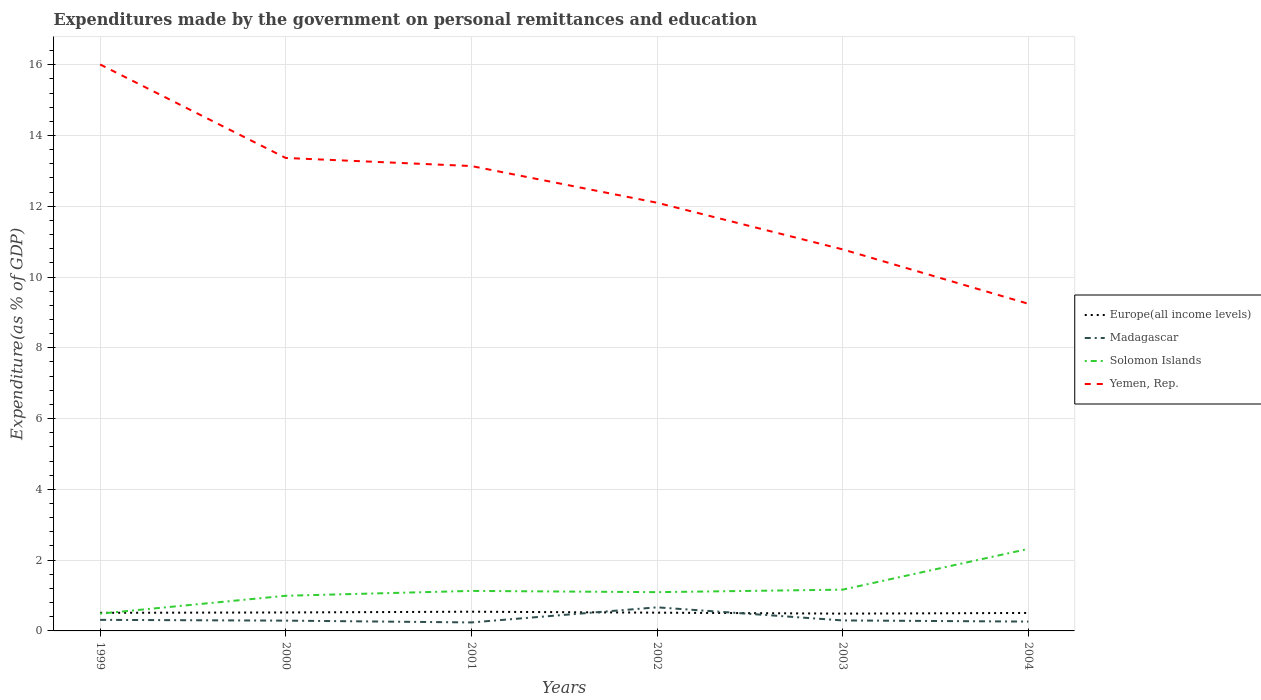How many different coloured lines are there?
Your answer should be very brief. 4. Across all years, what is the maximum expenditures made by the government on personal remittances and education in Madagascar?
Give a very brief answer. 0.24. In which year was the expenditures made by the government on personal remittances and education in Solomon Islands maximum?
Ensure brevity in your answer.  1999. What is the total expenditures made by the government on personal remittances and education in Madagascar in the graph?
Offer a terse response. 0.02. What is the difference between the highest and the second highest expenditures made by the government on personal remittances and education in Yemen, Rep.?
Your answer should be compact. 6.76. What is the difference between the highest and the lowest expenditures made by the government on personal remittances and education in Yemen, Rep.?
Offer a very short reply. 3. Is the expenditures made by the government on personal remittances and education in Yemen, Rep. strictly greater than the expenditures made by the government on personal remittances and education in Solomon Islands over the years?
Provide a succinct answer. No. How many years are there in the graph?
Give a very brief answer. 6. What is the difference between two consecutive major ticks on the Y-axis?
Keep it short and to the point. 2. How many legend labels are there?
Provide a short and direct response. 4. What is the title of the graph?
Provide a short and direct response. Expenditures made by the government on personal remittances and education. Does "Nepal" appear as one of the legend labels in the graph?
Offer a very short reply. No. What is the label or title of the X-axis?
Your answer should be very brief. Years. What is the label or title of the Y-axis?
Keep it short and to the point. Expenditure(as % of GDP). What is the Expenditure(as % of GDP) in Europe(all income levels) in 1999?
Your answer should be compact. 0.51. What is the Expenditure(as % of GDP) of Madagascar in 1999?
Provide a short and direct response. 0.31. What is the Expenditure(as % of GDP) in Solomon Islands in 1999?
Provide a succinct answer. 0.49. What is the Expenditure(as % of GDP) in Yemen, Rep. in 1999?
Keep it short and to the point. 16.01. What is the Expenditure(as % of GDP) in Europe(all income levels) in 2000?
Your response must be concise. 0.52. What is the Expenditure(as % of GDP) in Madagascar in 2000?
Your answer should be very brief. 0.29. What is the Expenditure(as % of GDP) in Solomon Islands in 2000?
Ensure brevity in your answer.  0.99. What is the Expenditure(as % of GDP) of Yemen, Rep. in 2000?
Your response must be concise. 13.37. What is the Expenditure(as % of GDP) of Europe(all income levels) in 2001?
Make the answer very short. 0.54. What is the Expenditure(as % of GDP) in Madagascar in 2001?
Offer a terse response. 0.24. What is the Expenditure(as % of GDP) of Solomon Islands in 2001?
Make the answer very short. 1.13. What is the Expenditure(as % of GDP) of Yemen, Rep. in 2001?
Offer a very short reply. 13.14. What is the Expenditure(as % of GDP) in Europe(all income levels) in 2002?
Provide a succinct answer. 0.52. What is the Expenditure(as % of GDP) in Madagascar in 2002?
Your response must be concise. 0.67. What is the Expenditure(as % of GDP) of Solomon Islands in 2002?
Your answer should be very brief. 1.1. What is the Expenditure(as % of GDP) in Yemen, Rep. in 2002?
Your answer should be compact. 12.1. What is the Expenditure(as % of GDP) in Europe(all income levels) in 2003?
Offer a terse response. 0.49. What is the Expenditure(as % of GDP) in Madagascar in 2003?
Your answer should be compact. 0.3. What is the Expenditure(as % of GDP) of Solomon Islands in 2003?
Make the answer very short. 1.17. What is the Expenditure(as % of GDP) of Yemen, Rep. in 2003?
Offer a very short reply. 10.78. What is the Expenditure(as % of GDP) of Europe(all income levels) in 2004?
Offer a very short reply. 0.51. What is the Expenditure(as % of GDP) of Madagascar in 2004?
Your response must be concise. 0.26. What is the Expenditure(as % of GDP) in Solomon Islands in 2004?
Offer a terse response. 2.32. What is the Expenditure(as % of GDP) in Yemen, Rep. in 2004?
Keep it short and to the point. 9.24. Across all years, what is the maximum Expenditure(as % of GDP) in Europe(all income levels)?
Your response must be concise. 0.54. Across all years, what is the maximum Expenditure(as % of GDP) of Madagascar?
Ensure brevity in your answer.  0.67. Across all years, what is the maximum Expenditure(as % of GDP) in Solomon Islands?
Your answer should be compact. 2.32. Across all years, what is the maximum Expenditure(as % of GDP) of Yemen, Rep.?
Provide a succinct answer. 16.01. Across all years, what is the minimum Expenditure(as % of GDP) of Europe(all income levels)?
Keep it short and to the point. 0.49. Across all years, what is the minimum Expenditure(as % of GDP) in Madagascar?
Give a very brief answer. 0.24. Across all years, what is the minimum Expenditure(as % of GDP) of Solomon Islands?
Offer a terse response. 0.49. Across all years, what is the minimum Expenditure(as % of GDP) of Yemen, Rep.?
Your response must be concise. 9.24. What is the total Expenditure(as % of GDP) of Europe(all income levels) in the graph?
Provide a short and direct response. 3.09. What is the total Expenditure(as % of GDP) of Madagascar in the graph?
Offer a terse response. 2.07. What is the total Expenditure(as % of GDP) in Solomon Islands in the graph?
Make the answer very short. 7.19. What is the total Expenditure(as % of GDP) of Yemen, Rep. in the graph?
Give a very brief answer. 74.64. What is the difference between the Expenditure(as % of GDP) of Europe(all income levels) in 1999 and that in 2000?
Your answer should be compact. -0.01. What is the difference between the Expenditure(as % of GDP) in Madagascar in 1999 and that in 2000?
Your response must be concise. 0.02. What is the difference between the Expenditure(as % of GDP) in Solomon Islands in 1999 and that in 2000?
Your response must be concise. -0.5. What is the difference between the Expenditure(as % of GDP) in Yemen, Rep. in 1999 and that in 2000?
Offer a very short reply. 2.64. What is the difference between the Expenditure(as % of GDP) in Europe(all income levels) in 1999 and that in 2001?
Your answer should be compact. -0.03. What is the difference between the Expenditure(as % of GDP) in Madagascar in 1999 and that in 2001?
Provide a succinct answer. 0.07. What is the difference between the Expenditure(as % of GDP) of Solomon Islands in 1999 and that in 2001?
Your response must be concise. -0.64. What is the difference between the Expenditure(as % of GDP) of Yemen, Rep. in 1999 and that in 2001?
Offer a terse response. 2.87. What is the difference between the Expenditure(as % of GDP) of Europe(all income levels) in 1999 and that in 2002?
Ensure brevity in your answer.  -0. What is the difference between the Expenditure(as % of GDP) of Madagascar in 1999 and that in 2002?
Make the answer very short. -0.35. What is the difference between the Expenditure(as % of GDP) in Solomon Islands in 1999 and that in 2002?
Provide a short and direct response. -0.61. What is the difference between the Expenditure(as % of GDP) in Yemen, Rep. in 1999 and that in 2002?
Ensure brevity in your answer.  3.91. What is the difference between the Expenditure(as % of GDP) of Europe(all income levels) in 1999 and that in 2003?
Give a very brief answer. 0.02. What is the difference between the Expenditure(as % of GDP) of Madagascar in 1999 and that in 2003?
Give a very brief answer. 0.02. What is the difference between the Expenditure(as % of GDP) in Solomon Islands in 1999 and that in 2003?
Keep it short and to the point. -0.68. What is the difference between the Expenditure(as % of GDP) in Yemen, Rep. in 1999 and that in 2003?
Provide a short and direct response. 5.23. What is the difference between the Expenditure(as % of GDP) of Europe(all income levels) in 1999 and that in 2004?
Provide a short and direct response. 0. What is the difference between the Expenditure(as % of GDP) in Madagascar in 1999 and that in 2004?
Give a very brief answer. 0.05. What is the difference between the Expenditure(as % of GDP) of Solomon Islands in 1999 and that in 2004?
Make the answer very short. -1.83. What is the difference between the Expenditure(as % of GDP) of Yemen, Rep. in 1999 and that in 2004?
Your answer should be very brief. 6.76. What is the difference between the Expenditure(as % of GDP) of Europe(all income levels) in 2000 and that in 2001?
Provide a succinct answer. -0.02. What is the difference between the Expenditure(as % of GDP) of Madagascar in 2000 and that in 2001?
Give a very brief answer. 0.05. What is the difference between the Expenditure(as % of GDP) in Solomon Islands in 2000 and that in 2001?
Provide a succinct answer. -0.14. What is the difference between the Expenditure(as % of GDP) of Yemen, Rep. in 2000 and that in 2001?
Keep it short and to the point. 0.23. What is the difference between the Expenditure(as % of GDP) of Europe(all income levels) in 2000 and that in 2002?
Provide a short and direct response. 0.01. What is the difference between the Expenditure(as % of GDP) in Madagascar in 2000 and that in 2002?
Ensure brevity in your answer.  -0.38. What is the difference between the Expenditure(as % of GDP) in Solomon Islands in 2000 and that in 2002?
Your answer should be compact. -0.1. What is the difference between the Expenditure(as % of GDP) in Yemen, Rep. in 2000 and that in 2002?
Your answer should be compact. 1.26. What is the difference between the Expenditure(as % of GDP) in Europe(all income levels) in 2000 and that in 2003?
Your answer should be compact. 0.03. What is the difference between the Expenditure(as % of GDP) in Madagascar in 2000 and that in 2003?
Offer a terse response. -0.01. What is the difference between the Expenditure(as % of GDP) in Solomon Islands in 2000 and that in 2003?
Offer a terse response. -0.17. What is the difference between the Expenditure(as % of GDP) in Yemen, Rep. in 2000 and that in 2003?
Give a very brief answer. 2.58. What is the difference between the Expenditure(as % of GDP) of Europe(all income levels) in 2000 and that in 2004?
Provide a succinct answer. 0.01. What is the difference between the Expenditure(as % of GDP) of Madagascar in 2000 and that in 2004?
Make the answer very short. 0.03. What is the difference between the Expenditure(as % of GDP) in Solomon Islands in 2000 and that in 2004?
Ensure brevity in your answer.  -1.32. What is the difference between the Expenditure(as % of GDP) of Yemen, Rep. in 2000 and that in 2004?
Your answer should be compact. 4.12. What is the difference between the Expenditure(as % of GDP) of Europe(all income levels) in 2001 and that in 2002?
Your answer should be very brief. 0.03. What is the difference between the Expenditure(as % of GDP) in Madagascar in 2001 and that in 2002?
Offer a very short reply. -0.43. What is the difference between the Expenditure(as % of GDP) of Solomon Islands in 2001 and that in 2002?
Your answer should be very brief. 0.04. What is the difference between the Expenditure(as % of GDP) of Yemen, Rep. in 2001 and that in 2002?
Offer a terse response. 1.04. What is the difference between the Expenditure(as % of GDP) in Europe(all income levels) in 2001 and that in 2003?
Offer a very short reply. 0.05. What is the difference between the Expenditure(as % of GDP) of Madagascar in 2001 and that in 2003?
Ensure brevity in your answer.  -0.06. What is the difference between the Expenditure(as % of GDP) of Solomon Islands in 2001 and that in 2003?
Ensure brevity in your answer.  -0.04. What is the difference between the Expenditure(as % of GDP) in Yemen, Rep. in 2001 and that in 2003?
Ensure brevity in your answer.  2.36. What is the difference between the Expenditure(as % of GDP) of Europe(all income levels) in 2001 and that in 2004?
Make the answer very short. 0.04. What is the difference between the Expenditure(as % of GDP) of Madagascar in 2001 and that in 2004?
Offer a very short reply. -0.02. What is the difference between the Expenditure(as % of GDP) of Solomon Islands in 2001 and that in 2004?
Make the answer very short. -1.19. What is the difference between the Expenditure(as % of GDP) of Yemen, Rep. in 2001 and that in 2004?
Ensure brevity in your answer.  3.89. What is the difference between the Expenditure(as % of GDP) in Europe(all income levels) in 2002 and that in 2003?
Provide a succinct answer. 0.03. What is the difference between the Expenditure(as % of GDP) in Madagascar in 2002 and that in 2003?
Make the answer very short. 0.37. What is the difference between the Expenditure(as % of GDP) of Solomon Islands in 2002 and that in 2003?
Offer a terse response. -0.07. What is the difference between the Expenditure(as % of GDP) in Yemen, Rep. in 2002 and that in 2003?
Provide a succinct answer. 1.32. What is the difference between the Expenditure(as % of GDP) of Europe(all income levels) in 2002 and that in 2004?
Your answer should be very brief. 0.01. What is the difference between the Expenditure(as % of GDP) in Madagascar in 2002 and that in 2004?
Ensure brevity in your answer.  0.4. What is the difference between the Expenditure(as % of GDP) in Solomon Islands in 2002 and that in 2004?
Your answer should be very brief. -1.22. What is the difference between the Expenditure(as % of GDP) of Yemen, Rep. in 2002 and that in 2004?
Provide a succinct answer. 2.86. What is the difference between the Expenditure(as % of GDP) in Europe(all income levels) in 2003 and that in 2004?
Offer a terse response. -0.02. What is the difference between the Expenditure(as % of GDP) in Madagascar in 2003 and that in 2004?
Ensure brevity in your answer.  0.03. What is the difference between the Expenditure(as % of GDP) of Solomon Islands in 2003 and that in 2004?
Make the answer very short. -1.15. What is the difference between the Expenditure(as % of GDP) in Yemen, Rep. in 2003 and that in 2004?
Give a very brief answer. 1.54. What is the difference between the Expenditure(as % of GDP) of Europe(all income levels) in 1999 and the Expenditure(as % of GDP) of Madagascar in 2000?
Your response must be concise. 0.22. What is the difference between the Expenditure(as % of GDP) in Europe(all income levels) in 1999 and the Expenditure(as % of GDP) in Solomon Islands in 2000?
Your answer should be compact. -0.48. What is the difference between the Expenditure(as % of GDP) in Europe(all income levels) in 1999 and the Expenditure(as % of GDP) in Yemen, Rep. in 2000?
Ensure brevity in your answer.  -12.85. What is the difference between the Expenditure(as % of GDP) of Madagascar in 1999 and the Expenditure(as % of GDP) of Solomon Islands in 2000?
Make the answer very short. -0.68. What is the difference between the Expenditure(as % of GDP) of Madagascar in 1999 and the Expenditure(as % of GDP) of Yemen, Rep. in 2000?
Your answer should be very brief. -13.05. What is the difference between the Expenditure(as % of GDP) in Solomon Islands in 1999 and the Expenditure(as % of GDP) in Yemen, Rep. in 2000?
Offer a very short reply. -12.88. What is the difference between the Expenditure(as % of GDP) of Europe(all income levels) in 1999 and the Expenditure(as % of GDP) of Madagascar in 2001?
Provide a short and direct response. 0.27. What is the difference between the Expenditure(as % of GDP) in Europe(all income levels) in 1999 and the Expenditure(as % of GDP) in Solomon Islands in 2001?
Ensure brevity in your answer.  -0.62. What is the difference between the Expenditure(as % of GDP) of Europe(all income levels) in 1999 and the Expenditure(as % of GDP) of Yemen, Rep. in 2001?
Keep it short and to the point. -12.63. What is the difference between the Expenditure(as % of GDP) in Madagascar in 1999 and the Expenditure(as % of GDP) in Solomon Islands in 2001?
Keep it short and to the point. -0.82. What is the difference between the Expenditure(as % of GDP) of Madagascar in 1999 and the Expenditure(as % of GDP) of Yemen, Rep. in 2001?
Make the answer very short. -12.83. What is the difference between the Expenditure(as % of GDP) in Solomon Islands in 1999 and the Expenditure(as % of GDP) in Yemen, Rep. in 2001?
Your response must be concise. -12.65. What is the difference between the Expenditure(as % of GDP) of Europe(all income levels) in 1999 and the Expenditure(as % of GDP) of Madagascar in 2002?
Your answer should be very brief. -0.16. What is the difference between the Expenditure(as % of GDP) in Europe(all income levels) in 1999 and the Expenditure(as % of GDP) in Solomon Islands in 2002?
Provide a short and direct response. -0.58. What is the difference between the Expenditure(as % of GDP) of Europe(all income levels) in 1999 and the Expenditure(as % of GDP) of Yemen, Rep. in 2002?
Offer a very short reply. -11.59. What is the difference between the Expenditure(as % of GDP) of Madagascar in 1999 and the Expenditure(as % of GDP) of Solomon Islands in 2002?
Give a very brief answer. -0.78. What is the difference between the Expenditure(as % of GDP) of Madagascar in 1999 and the Expenditure(as % of GDP) of Yemen, Rep. in 2002?
Make the answer very short. -11.79. What is the difference between the Expenditure(as % of GDP) in Solomon Islands in 1999 and the Expenditure(as % of GDP) in Yemen, Rep. in 2002?
Give a very brief answer. -11.61. What is the difference between the Expenditure(as % of GDP) in Europe(all income levels) in 1999 and the Expenditure(as % of GDP) in Madagascar in 2003?
Ensure brevity in your answer.  0.22. What is the difference between the Expenditure(as % of GDP) in Europe(all income levels) in 1999 and the Expenditure(as % of GDP) in Solomon Islands in 2003?
Give a very brief answer. -0.65. What is the difference between the Expenditure(as % of GDP) in Europe(all income levels) in 1999 and the Expenditure(as % of GDP) in Yemen, Rep. in 2003?
Provide a short and direct response. -10.27. What is the difference between the Expenditure(as % of GDP) in Madagascar in 1999 and the Expenditure(as % of GDP) in Solomon Islands in 2003?
Provide a succinct answer. -0.85. What is the difference between the Expenditure(as % of GDP) of Madagascar in 1999 and the Expenditure(as % of GDP) of Yemen, Rep. in 2003?
Offer a terse response. -10.47. What is the difference between the Expenditure(as % of GDP) of Solomon Islands in 1999 and the Expenditure(as % of GDP) of Yemen, Rep. in 2003?
Keep it short and to the point. -10.29. What is the difference between the Expenditure(as % of GDP) of Europe(all income levels) in 1999 and the Expenditure(as % of GDP) of Madagascar in 2004?
Your response must be concise. 0.25. What is the difference between the Expenditure(as % of GDP) in Europe(all income levels) in 1999 and the Expenditure(as % of GDP) in Solomon Islands in 2004?
Provide a succinct answer. -1.81. What is the difference between the Expenditure(as % of GDP) in Europe(all income levels) in 1999 and the Expenditure(as % of GDP) in Yemen, Rep. in 2004?
Provide a short and direct response. -8.73. What is the difference between the Expenditure(as % of GDP) in Madagascar in 1999 and the Expenditure(as % of GDP) in Solomon Islands in 2004?
Provide a succinct answer. -2.01. What is the difference between the Expenditure(as % of GDP) of Madagascar in 1999 and the Expenditure(as % of GDP) of Yemen, Rep. in 2004?
Make the answer very short. -8.93. What is the difference between the Expenditure(as % of GDP) of Solomon Islands in 1999 and the Expenditure(as % of GDP) of Yemen, Rep. in 2004?
Make the answer very short. -8.76. What is the difference between the Expenditure(as % of GDP) of Europe(all income levels) in 2000 and the Expenditure(as % of GDP) of Madagascar in 2001?
Provide a short and direct response. 0.28. What is the difference between the Expenditure(as % of GDP) of Europe(all income levels) in 2000 and the Expenditure(as % of GDP) of Solomon Islands in 2001?
Make the answer very short. -0.61. What is the difference between the Expenditure(as % of GDP) of Europe(all income levels) in 2000 and the Expenditure(as % of GDP) of Yemen, Rep. in 2001?
Your response must be concise. -12.62. What is the difference between the Expenditure(as % of GDP) in Madagascar in 2000 and the Expenditure(as % of GDP) in Solomon Islands in 2001?
Offer a terse response. -0.84. What is the difference between the Expenditure(as % of GDP) of Madagascar in 2000 and the Expenditure(as % of GDP) of Yemen, Rep. in 2001?
Provide a short and direct response. -12.85. What is the difference between the Expenditure(as % of GDP) of Solomon Islands in 2000 and the Expenditure(as % of GDP) of Yemen, Rep. in 2001?
Keep it short and to the point. -12.14. What is the difference between the Expenditure(as % of GDP) of Europe(all income levels) in 2000 and the Expenditure(as % of GDP) of Madagascar in 2002?
Offer a terse response. -0.15. What is the difference between the Expenditure(as % of GDP) of Europe(all income levels) in 2000 and the Expenditure(as % of GDP) of Solomon Islands in 2002?
Your answer should be compact. -0.57. What is the difference between the Expenditure(as % of GDP) in Europe(all income levels) in 2000 and the Expenditure(as % of GDP) in Yemen, Rep. in 2002?
Keep it short and to the point. -11.58. What is the difference between the Expenditure(as % of GDP) in Madagascar in 2000 and the Expenditure(as % of GDP) in Solomon Islands in 2002?
Offer a very short reply. -0.81. What is the difference between the Expenditure(as % of GDP) of Madagascar in 2000 and the Expenditure(as % of GDP) of Yemen, Rep. in 2002?
Keep it short and to the point. -11.81. What is the difference between the Expenditure(as % of GDP) in Solomon Islands in 2000 and the Expenditure(as % of GDP) in Yemen, Rep. in 2002?
Ensure brevity in your answer.  -11.11. What is the difference between the Expenditure(as % of GDP) of Europe(all income levels) in 2000 and the Expenditure(as % of GDP) of Madagascar in 2003?
Offer a terse response. 0.23. What is the difference between the Expenditure(as % of GDP) of Europe(all income levels) in 2000 and the Expenditure(as % of GDP) of Solomon Islands in 2003?
Make the answer very short. -0.64. What is the difference between the Expenditure(as % of GDP) of Europe(all income levels) in 2000 and the Expenditure(as % of GDP) of Yemen, Rep. in 2003?
Give a very brief answer. -10.26. What is the difference between the Expenditure(as % of GDP) of Madagascar in 2000 and the Expenditure(as % of GDP) of Solomon Islands in 2003?
Make the answer very short. -0.88. What is the difference between the Expenditure(as % of GDP) in Madagascar in 2000 and the Expenditure(as % of GDP) in Yemen, Rep. in 2003?
Your answer should be compact. -10.49. What is the difference between the Expenditure(as % of GDP) in Solomon Islands in 2000 and the Expenditure(as % of GDP) in Yemen, Rep. in 2003?
Give a very brief answer. -9.79. What is the difference between the Expenditure(as % of GDP) in Europe(all income levels) in 2000 and the Expenditure(as % of GDP) in Madagascar in 2004?
Your answer should be compact. 0.26. What is the difference between the Expenditure(as % of GDP) of Europe(all income levels) in 2000 and the Expenditure(as % of GDP) of Solomon Islands in 2004?
Provide a short and direct response. -1.8. What is the difference between the Expenditure(as % of GDP) of Europe(all income levels) in 2000 and the Expenditure(as % of GDP) of Yemen, Rep. in 2004?
Your response must be concise. -8.72. What is the difference between the Expenditure(as % of GDP) of Madagascar in 2000 and the Expenditure(as % of GDP) of Solomon Islands in 2004?
Keep it short and to the point. -2.03. What is the difference between the Expenditure(as % of GDP) in Madagascar in 2000 and the Expenditure(as % of GDP) in Yemen, Rep. in 2004?
Your answer should be compact. -8.95. What is the difference between the Expenditure(as % of GDP) of Solomon Islands in 2000 and the Expenditure(as % of GDP) of Yemen, Rep. in 2004?
Ensure brevity in your answer.  -8.25. What is the difference between the Expenditure(as % of GDP) in Europe(all income levels) in 2001 and the Expenditure(as % of GDP) in Madagascar in 2002?
Offer a very short reply. -0.12. What is the difference between the Expenditure(as % of GDP) in Europe(all income levels) in 2001 and the Expenditure(as % of GDP) in Solomon Islands in 2002?
Your response must be concise. -0.55. What is the difference between the Expenditure(as % of GDP) in Europe(all income levels) in 2001 and the Expenditure(as % of GDP) in Yemen, Rep. in 2002?
Your answer should be very brief. -11.56. What is the difference between the Expenditure(as % of GDP) of Madagascar in 2001 and the Expenditure(as % of GDP) of Solomon Islands in 2002?
Offer a very short reply. -0.86. What is the difference between the Expenditure(as % of GDP) in Madagascar in 2001 and the Expenditure(as % of GDP) in Yemen, Rep. in 2002?
Your response must be concise. -11.86. What is the difference between the Expenditure(as % of GDP) in Solomon Islands in 2001 and the Expenditure(as % of GDP) in Yemen, Rep. in 2002?
Give a very brief answer. -10.97. What is the difference between the Expenditure(as % of GDP) in Europe(all income levels) in 2001 and the Expenditure(as % of GDP) in Madagascar in 2003?
Offer a very short reply. 0.25. What is the difference between the Expenditure(as % of GDP) in Europe(all income levels) in 2001 and the Expenditure(as % of GDP) in Solomon Islands in 2003?
Provide a succinct answer. -0.62. What is the difference between the Expenditure(as % of GDP) in Europe(all income levels) in 2001 and the Expenditure(as % of GDP) in Yemen, Rep. in 2003?
Provide a short and direct response. -10.24. What is the difference between the Expenditure(as % of GDP) in Madagascar in 2001 and the Expenditure(as % of GDP) in Solomon Islands in 2003?
Provide a succinct answer. -0.93. What is the difference between the Expenditure(as % of GDP) in Madagascar in 2001 and the Expenditure(as % of GDP) in Yemen, Rep. in 2003?
Ensure brevity in your answer.  -10.54. What is the difference between the Expenditure(as % of GDP) in Solomon Islands in 2001 and the Expenditure(as % of GDP) in Yemen, Rep. in 2003?
Give a very brief answer. -9.65. What is the difference between the Expenditure(as % of GDP) of Europe(all income levels) in 2001 and the Expenditure(as % of GDP) of Madagascar in 2004?
Keep it short and to the point. 0.28. What is the difference between the Expenditure(as % of GDP) in Europe(all income levels) in 2001 and the Expenditure(as % of GDP) in Solomon Islands in 2004?
Ensure brevity in your answer.  -1.78. What is the difference between the Expenditure(as % of GDP) in Europe(all income levels) in 2001 and the Expenditure(as % of GDP) in Yemen, Rep. in 2004?
Keep it short and to the point. -8.7. What is the difference between the Expenditure(as % of GDP) in Madagascar in 2001 and the Expenditure(as % of GDP) in Solomon Islands in 2004?
Give a very brief answer. -2.08. What is the difference between the Expenditure(as % of GDP) in Madagascar in 2001 and the Expenditure(as % of GDP) in Yemen, Rep. in 2004?
Offer a terse response. -9. What is the difference between the Expenditure(as % of GDP) in Solomon Islands in 2001 and the Expenditure(as % of GDP) in Yemen, Rep. in 2004?
Give a very brief answer. -8.11. What is the difference between the Expenditure(as % of GDP) of Europe(all income levels) in 2002 and the Expenditure(as % of GDP) of Madagascar in 2003?
Provide a short and direct response. 0.22. What is the difference between the Expenditure(as % of GDP) in Europe(all income levels) in 2002 and the Expenditure(as % of GDP) in Solomon Islands in 2003?
Your answer should be compact. -0.65. What is the difference between the Expenditure(as % of GDP) in Europe(all income levels) in 2002 and the Expenditure(as % of GDP) in Yemen, Rep. in 2003?
Make the answer very short. -10.27. What is the difference between the Expenditure(as % of GDP) in Madagascar in 2002 and the Expenditure(as % of GDP) in Solomon Islands in 2003?
Your response must be concise. -0.5. What is the difference between the Expenditure(as % of GDP) in Madagascar in 2002 and the Expenditure(as % of GDP) in Yemen, Rep. in 2003?
Provide a short and direct response. -10.12. What is the difference between the Expenditure(as % of GDP) in Solomon Islands in 2002 and the Expenditure(as % of GDP) in Yemen, Rep. in 2003?
Your answer should be very brief. -9.69. What is the difference between the Expenditure(as % of GDP) of Europe(all income levels) in 2002 and the Expenditure(as % of GDP) of Madagascar in 2004?
Make the answer very short. 0.25. What is the difference between the Expenditure(as % of GDP) in Europe(all income levels) in 2002 and the Expenditure(as % of GDP) in Solomon Islands in 2004?
Your answer should be very brief. -1.8. What is the difference between the Expenditure(as % of GDP) in Europe(all income levels) in 2002 and the Expenditure(as % of GDP) in Yemen, Rep. in 2004?
Your response must be concise. -8.73. What is the difference between the Expenditure(as % of GDP) of Madagascar in 2002 and the Expenditure(as % of GDP) of Solomon Islands in 2004?
Your answer should be compact. -1.65. What is the difference between the Expenditure(as % of GDP) in Madagascar in 2002 and the Expenditure(as % of GDP) in Yemen, Rep. in 2004?
Offer a terse response. -8.58. What is the difference between the Expenditure(as % of GDP) in Solomon Islands in 2002 and the Expenditure(as % of GDP) in Yemen, Rep. in 2004?
Keep it short and to the point. -8.15. What is the difference between the Expenditure(as % of GDP) of Europe(all income levels) in 2003 and the Expenditure(as % of GDP) of Madagascar in 2004?
Offer a terse response. 0.23. What is the difference between the Expenditure(as % of GDP) of Europe(all income levels) in 2003 and the Expenditure(as % of GDP) of Solomon Islands in 2004?
Ensure brevity in your answer.  -1.83. What is the difference between the Expenditure(as % of GDP) in Europe(all income levels) in 2003 and the Expenditure(as % of GDP) in Yemen, Rep. in 2004?
Ensure brevity in your answer.  -8.76. What is the difference between the Expenditure(as % of GDP) in Madagascar in 2003 and the Expenditure(as % of GDP) in Solomon Islands in 2004?
Provide a short and direct response. -2.02. What is the difference between the Expenditure(as % of GDP) of Madagascar in 2003 and the Expenditure(as % of GDP) of Yemen, Rep. in 2004?
Keep it short and to the point. -8.95. What is the difference between the Expenditure(as % of GDP) in Solomon Islands in 2003 and the Expenditure(as % of GDP) in Yemen, Rep. in 2004?
Keep it short and to the point. -8.08. What is the average Expenditure(as % of GDP) of Europe(all income levels) per year?
Provide a short and direct response. 0.51. What is the average Expenditure(as % of GDP) in Madagascar per year?
Keep it short and to the point. 0.35. What is the average Expenditure(as % of GDP) in Solomon Islands per year?
Your answer should be very brief. 1.2. What is the average Expenditure(as % of GDP) in Yemen, Rep. per year?
Provide a short and direct response. 12.44. In the year 1999, what is the difference between the Expenditure(as % of GDP) in Europe(all income levels) and Expenditure(as % of GDP) in Madagascar?
Offer a very short reply. 0.2. In the year 1999, what is the difference between the Expenditure(as % of GDP) of Europe(all income levels) and Expenditure(as % of GDP) of Solomon Islands?
Make the answer very short. 0.02. In the year 1999, what is the difference between the Expenditure(as % of GDP) of Europe(all income levels) and Expenditure(as % of GDP) of Yemen, Rep.?
Give a very brief answer. -15.5. In the year 1999, what is the difference between the Expenditure(as % of GDP) of Madagascar and Expenditure(as % of GDP) of Solomon Islands?
Offer a very short reply. -0.18. In the year 1999, what is the difference between the Expenditure(as % of GDP) in Madagascar and Expenditure(as % of GDP) in Yemen, Rep.?
Offer a very short reply. -15.7. In the year 1999, what is the difference between the Expenditure(as % of GDP) in Solomon Islands and Expenditure(as % of GDP) in Yemen, Rep.?
Offer a very short reply. -15.52. In the year 2000, what is the difference between the Expenditure(as % of GDP) in Europe(all income levels) and Expenditure(as % of GDP) in Madagascar?
Your answer should be compact. 0.23. In the year 2000, what is the difference between the Expenditure(as % of GDP) of Europe(all income levels) and Expenditure(as % of GDP) of Solomon Islands?
Give a very brief answer. -0.47. In the year 2000, what is the difference between the Expenditure(as % of GDP) in Europe(all income levels) and Expenditure(as % of GDP) in Yemen, Rep.?
Offer a terse response. -12.84. In the year 2000, what is the difference between the Expenditure(as % of GDP) in Madagascar and Expenditure(as % of GDP) in Solomon Islands?
Your answer should be very brief. -0.7. In the year 2000, what is the difference between the Expenditure(as % of GDP) of Madagascar and Expenditure(as % of GDP) of Yemen, Rep.?
Your response must be concise. -13.08. In the year 2000, what is the difference between the Expenditure(as % of GDP) of Solomon Islands and Expenditure(as % of GDP) of Yemen, Rep.?
Offer a terse response. -12.37. In the year 2001, what is the difference between the Expenditure(as % of GDP) of Europe(all income levels) and Expenditure(as % of GDP) of Madagascar?
Ensure brevity in your answer.  0.3. In the year 2001, what is the difference between the Expenditure(as % of GDP) in Europe(all income levels) and Expenditure(as % of GDP) in Solomon Islands?
Your response must be concise. -0.59. In the year 2001, what is the difference between the Expenditure(as % of GDP) of Europe(all income levels) and Expenditure(as % of GDP) of Yemen, Rep.?
Your answer should be compact. -12.59. In the year 2001, what is the difference between the Expenditure(as % of GDP) of Madagascar and Expenditure(as % of GDP) of Solomon Islands?
Give a very brief answer. -0.89. In the year 2001, what is the difference between the Expenditure(as % of GDP) in Madagascar and Expenditure(as % of GDP) in Yemen, Rep.?
Your response must be concise. -12.9. In the year 2001, what is the difference between the Expenditure(as % of GDP) in Solomon Islands and Expenditure(as % of GDP) in Yemen, Rep.?
Ensure brevity in your answer.  -12.01. In the year 2002, what is the difference between the Expenditure(as % of GDP) in Europe(all income levels) and Expenditure(as % of GDP) in Madagascar?
Make the answer very short. -0.15. In the year 2002, what is the difference between the Expenditure(as % of GDP) in Europe(all income levels) and Expenditure(as % of GDP) in Solomon Islands?
Your answer should be very brief. -0.58. In the year 2002, what is the difference between the Expenditure(as % of GDP) of Europe(all income levels) and Expenditure(as % of GDP) of Yemen, Rep.?
Your response must be concise. -11.59. In the year 2002, what is the difference between the Expenditure(as % of GDP) in Madagascar and Expenditure(as % of GDP) in Solomon Islands?
Offer a terse response. -0.43. In the year 2002, what is the difference between the Expenditure(as % of GDP) of Madagascar and Expenditure(as % of GDP) of Yemen, Rep.?
Ensure brevity in your answer.  -11.43. In the year 2002, what is the difference between the Expenditure(as % of GDP) of Solomon Islands and Expenditure(as % of GDP) of Yemen, Rep.?
Make the answer very short. -11.01. In the year 2003, what is the difference between the Expenditure(as % of GDP) in Europe(all income levels) and Expenditure(as % of GDP) in Madagascar?
Your response must be concise. 0.19. In the year 2003, what is the difference between the Expenditure(as % of GDP) in Europe(all income levels) and Expenditure(as % of GDP) in Solomon Islands?
Your answer should be very brief. -0.68. In the year 2003, what is the difference between the Expenditure(as % of GDP) of Europe(all income levels) and Expenditure(as % of GDP) of Yemen, Rep.?
Give a very brief answer. -10.29. In the year 2003, what is the difference between the Expenditure(as % of GDP) in Madagascar and Expenditure(as % of GDP) in Solomon Islands?
Ensure brevity in your answer.  -0.87. In the year 2003, what is the difference between the Expenditure(as % of GDP) of Madagascar and Expenditure(as % of GDP) of Yemen, Rep.?
Provide a succinct answer. -10.49. In the year 2003, what is the difference between the Expenditure(as % of GDP) of Solomon Islands and Expenditure(as % of GDP) of Yemen, Rep.?
Provide a succinct answer. -9.62. In the year 2004, what is the difference between the Expenditure(as % of GDP) in Europe(all income levels) and Expenditure(as % of GDP) in Madagascar?
Offer a terse response. 0.24. In the year 2004, what is the difference between the Expenditure(as % of GDP) of Europe(all income levels) and Expenditure(as % of GDP) of Solomon Islands?
Your answer should be very brief. -1.81. In the year 2004, what is the difference between the Expenditure(as % of GDP) in Europe(all income levels) and Expenditure(as % of GDP) in Yemen, Rep.?
Provide a short and direct response. -8.74. In the year 2004, what is the difference between the Expenditure(as % of GDP) of Madagascar and Expenditure(as % of GDP) of Solomon Islands?
Provide a short and direct response. -2.05. In the year 2004, what is the difference between the Expenditure(as % of GDP) of Madagascar and Expenditure(as % of GDP) of Yemen, Rep.?
Ensure brevity in your answer.  -8.98. In the year 2004, what is the difference between the Expenditure(as % of GDP) of Solomon Islands and Expenditure(as % of GDP) of Yemen, Rep.?
Provide a short and direct response. -6.93. What is the ratio of the Expenditure(as % of GDP) in Europe(all income levels) in 1999 to that in 2000?
Give a very brief answer. 0.98. What is the ratio of the Expenditure(as % of GDP) of Madagascar in 1999 to that in 2000?
Offer a very short reply. 1.08. What is the ratio of the Expenditure(as % of GDP) of Solomon Islands in 1999 to that in 2000?
Offer a terse response. 0.49. What is the ratio of the Expenditure(as % of GDP) of Yemen, Rep. in 1999 to that in 2000?
Give a very brief answer. 1.2. What is the ratio of the Expenditure(as % of GDP) of Europe(all income levels) in 1999 to that in 2001?
Give a very brief answer. 0.94. What is the ratio of the Expenditure(as % of GDP) in Madagascar in 1999 to that in 2001?
Make the answer very short. 1.3. What is the ratio of the Expenditure(as % of GDP) in Solomon Islands in 1999 to that in 2001?
Make the answer very short. 0.43. What is the ratio of the Expenditure(as % of GDP) of Yemen, Rep. in 1999 to that in 2001?
Give a very brief answer. 1.22. What is the ratio of the Expenditure(as % of GDP) of Madagascar in 1999 to that in 2002?
Your answer should be very brief. 0.47. What is the ratio of the Expenditure(as % of GDP) of Solomon Islands in 1999 to that in 2002?
Your answer should be compact. 0.45. What is the ratio of the Expenditure(as % of GDP) of Yemen, Rep. in 1999 to that in 2002?
Give a very brief answer. 1.32. What is the ratio of the Expenditure(as % of GDP) of Europe(all income levels) in 1999 to that in 2003?
Provide a succinct answer. 1.05. What is the ratio of the Expenditure(as % of GDP) of Madagascar in 1999 to that in 2003?
Your answer should be compact. 1.05. What is the ratio of the Expenditure(as % of GDP) in Solomon Islands in 1999 to that in 2003?
Keep it short and to the point. 0.42. What is the ratio of the Expenditure(as % of GDP) in Yemen, Rep. in 1999 to that in 2003?
Offer a very short reply. 1.48. What is the ratio of the Expenditure(as % of GDP) in Europe(all income levels) in 1999 to that in 2004?
Provide a short and direct response. 1.01. What is the ratio of the Expenditure(as % of GDP) of Madagascar in 1999 to that in 2004?
Your response must be concise. 1.19. What is the ratio of the Expenditure(as % of GDP) in Solomon Islands in 1999 to that in 2004?
Keep it short and to the point. 0.21. What is the ratio of the Expenditure(as % of GDP) in Yemen, Rep. in 1999 to that in 2004?
Provide a succinct answer. 1.73. What is the ratio of the Expenditure(as % of GDP) in Europe(all income levels) in 2000 to that in 2001?
Offer a very short reply. 0.96. What is the ratio of the Expenditure(as % of GDP) of Madagascar in 2000 to that in 2001?
Offer a terse response. 1.21. What is the ratio of the Expenditure(as % of GDP) in Solomon Islands in 2000 to that in 2001?
Offer a very short reply. 0.88. What is the ratio of the Expenditure(as % of GDP) in Yemen, Rep. in 2000 to that in 2001?
Your response must be concise. 1.02. What is the ratio of the Expenditure(as % of GDP) in Europe(all income levels) in 2000 to that in 2002?
Your answer should be very brief. 1.01. What is the ratio of the Expenditure(as % of GDP) in Madagascar in 2000 to that in 2002?
Your answer should be very brief. 0.44. What is the ratio of the Expenditure(as % of GDP) of Solomon Islands in 2000 to that in 2002?
Give a very brief answer. 0.91. What is the ratio of the Expenditure(as % of GDP) of Yemen, Rep. in 2000 to that in 2002?
Give a very brief answer. 1.1. What is the ratio of the Expenditure(as % of GDP) in Europe(all income levels) in 2000 to that in 2003?
Offer a very short reply. 1.07. What is the ratio of the Expenditure(as % of GDP) in Madagascar in 2000 to that in 2003?
Your answer should be compact. 0.98. What is the ratio of the Expenditure(as % of GDP) of Solomon Islands in 2000 to that in 2003?
Make the answer very short. 0.85. What is the ratio of the Expenditure(as % of GDP) in Yemen, Rep. in 2000 to that in 2003?
Your response must be concise. 1.24. What is the ratio of the Expenditure(as % of GDP) in Europe(all income levels) in 2000 to that in 2004?
Make the answer very short. 1.03. What is the ratio of the Expenditure(as % of GDP) of Madagascar in 2000 to that in 2004?
Provide a short and direct response. 1.1. What is the ratio of the Expenditure(as % of GDP) in Solomon Islands in 2000 to that in 2004?
Give a very brief answer. 0.43. What is the ratio of the Expenditure(as % of GDP) of Yemen, Rep. in 2000 to that in 2004?
Provide a succinct answer. 1.45. What is the ratio of the Expenditure(as % of GDP) of Europe(all income levels) in 2001 to that in 2002?
Give a very brief answer. 1.05. What is the ratio of the Expenditure(as % of GDP) of Madagascar in 2001 to that in 2002?
Ensure brevity in your answer.  0.36. What is the ratio of the Expenditure(as % of GDP) of Solomon Islands in 2001 to that in 2002?
Ensure brevity in your answer.  1.03. What is the ratio of the Expenditure(as % of GDP) in Yemen, Rep. in 2001 to that in 2002?
Provide a succinct answer. 1.09. What is the ratio of the Expenditure(as % of GDP) in Europe(all income levels) in 2001 to that in 2003?
Provide a succinct answer. 1.11. What is the ratio of the Expenditure(as % of GDP) of Madagascar in 2001 to that in 2003?
Offer a very short reply. 0.81. What is the ratio of the Expenditure(as % of GDP) in Solomon Islands in 2001 to that in 2003?
Ensure brevity in your answer.  0.97. What is the ratio of the Expenditure(as % of GDP) in Yemen, Rep. in 2001 to that in 2003?
Make the answer very short. 1.22. What is the ratio of the Expenditure(as % of GDP) of Europe(all income levels) in 2001 to that in 2004?
Your answer should be compact. 1.07. What is the ratio of the Expenditure(as % of GDP) in Madagascar in 2001 to that in 2004?
Offer a very short reply. 0.91. What is the ratio of the Expenditure(as % of GDP) in Solomon Islands in 2001 to that in 2004?
Make the answer very short. 0.49. What is the ratio of the Expenditure(as % of GDP) in Yemen, Rep. in 2001 to that in 2004?
Offer a terse response. 1.42. What is the ratio of the Expenditure(as % of GDP) in Europe(all income levels) in 2002 to that in 2003?
Keep it short and to the point. 1.06. What is the ratio of the Expenditure(as % of GDP) in Madagascar in 2002 to that in 2003?
Your answer should be very brief. 2.25. What is the ratio of the Expenditure(as % of GDP) in Solomon Islands in 2002 to that in 2003?
Your response must be concise. 0.94. What is the ratio of the Expenditure(as % of GDP) in Yemen, Rep. in 2002 to that in 2003?
Your response must be concise. 1.12. What is the ratio of the Expenditure(as % of GDP) of Europe(all income levels) in 2002 to that in 2004?
Make the answer very short. 1.02. What is the ratio of the Expenditure(as % of GDP) of Madagascar in 2002 to that in 2004?
Your response must be concise. 2.53. What is the ratio of the Expenditure(as % of GDP) of Solomon Islands in 2002 to that in 2004?
Your answer should be very brief. 0.47. What is the ratio of the Expenditure(as % of GDP) of Yemen, Rep. in 2002 to that in 2004?
Your answer should be compact. 1.31. What is the ratio of the Expenditure(as % of GDP) of Europe(all income levels) in 2003 to that in 2004?
Your response must be concise. 0.96. What is the ratio of the Expenditure(as % of GDP) in Madagascar in 2003 to that in 2004?
Keep it short and to the point. 1.12. What is the ratio of the Expenditure(as % of GDP) of Solomon Islands in 2003 to that in 2004?
Your answer should be very brief. 0.5. What is the ratio of the Expenditure(as % of GDP) of Yemen, Rep. in 2003 to that in 2004?
Give a very brief answer. 1.17. What is the difference between the highest and the second highest Expenditure(as % of GDP) in Europe(all income levels)?
Your answer should be compact. 0.02. What is the difference between the highest and the second highest Expenditure(as % of GDP) of Madagascar?
Ensure brevity in your answer.  0.35. What is the difference between the highest and the second highest Expenditure(as % of GDP) in Solomon Islands?
Offer a terse response. 1.15. What is the difference between the highest and the second highest Expenditure(as % of GDP) in Yemen, Rep.?
Provide a succinct answer. 2.64. What is the difference between the highest and the lowest Expenditure(as % of GDP) of Europe(all income levels)?
Provide a succinct answer. 0.05. What is the difference between the highest and the lowest Expenditure(as % of GDP) in Madagascar?
Provide a short and direct response. 0.43. What is the difference between the highest and the lowest Expenditure(as % of GDP) in Solomon Islands?
Make the answer very short. 1.83. What is the difference between the highest and the lowest Expenditure(as % of GDP) in Yemen, Rep.?
Offer a terse response. 6.76. 